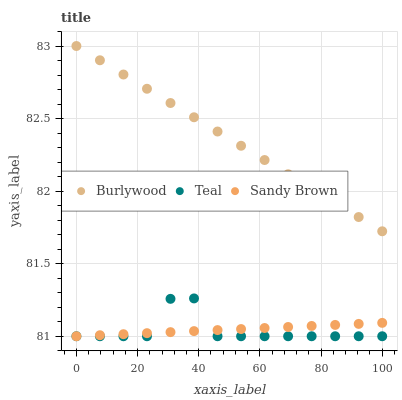Does Teal have the minimum area under the curve?
Answer yes or no. Yes. Does Burlywood have the maximum area under the curve?
Answer yes or no. Yes. Does Sandy Brown have the minimum area under the curve?
Answer yes or no. No. Does Sandy Brown have the maximum area under the curve?
Answer yes or no. No. Is Burlywood the smoothest?
Answer yes or no. Yes. Is Teal the roughest?
Answer yes or no. Yes. Is Sandy Brown the smoothest?
Answer yes or no. No. Is Sandy Brown the roughest?
Answer yes or no. No. Does Sandy Brown have the lowest value?
Answer yes or no. Yes. Does Burlywood have the highest value?
Answer yes or no. Yes. Does Teal have the highest value?
Answer yes or no. No. Is Sandy Brown less than Burlywood?
Answer yes or no. Yes. Is Burlywood greater than Sandy Brown?
Answer yes or no. Yes. Does Teal intersect Sandy Brown?
Answer yes or no. Yes. Is Teal less than Sandy Brown?
Answer yes or no. No. Is Teal greater than Sandy Brown?
Answer yes or no. No. Does Sandy Brown intersect Burlywood?
Answer yes or no. No. 